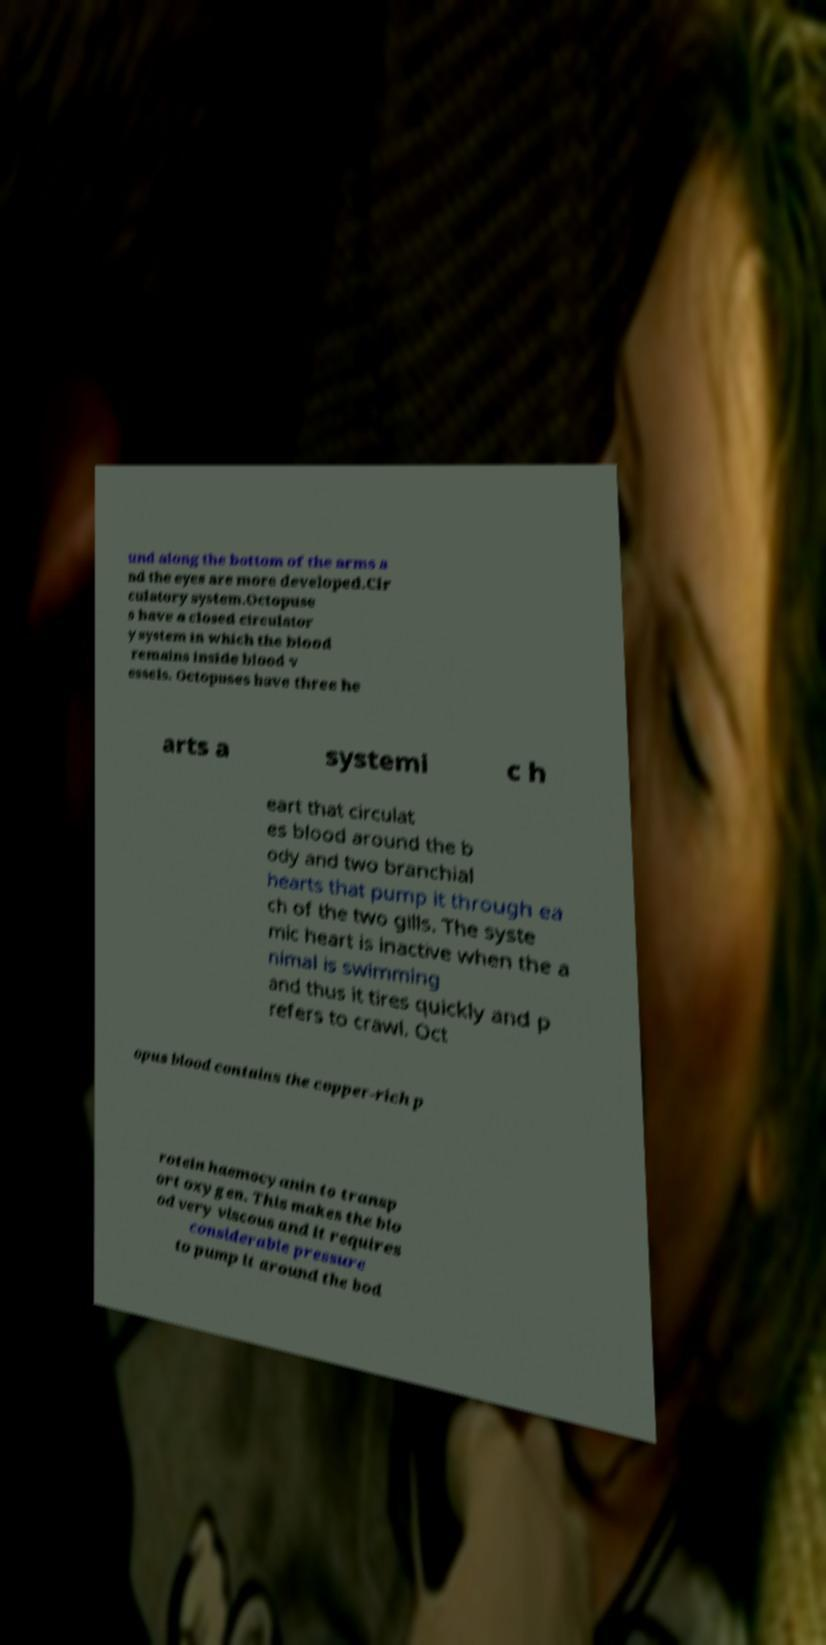What messages or text are displayed in this image? I need them in a readable, typed format. und along the bottom of the arms a nd the eyes are more developed.Cir culatory system.Octopuse s have a closed circulator y system in which the blood remains inside blood v essels. Octopuses have three he arts a systemi c h eart that circulat es blood around the b ody and two branchial hearts that pump it through ea ch of the two gills. The syste mic heart is inactive when the a nimal is swimming and thus it tires quickly and p refers to crawl. Oct opus blood contains the copper-rich p rotein haemocyanin to transp ort oxygen. This makes the blo od very viscous and it requires considerable pressure to pump it around the bod 